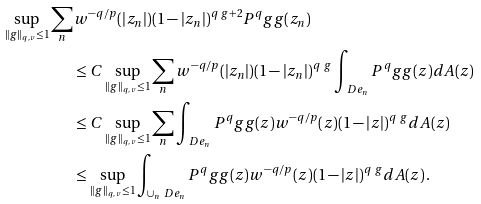<formula> <loc_0><loc_0><loc_500><loc_500>\sup _ { \| g \| _ { q , v } \leq 1 } \sum _ { n } & w ^ { - q / p } ( | z _ { n } | ) ( 1 - | z _ { n } | ) ^ { q \ g + 2 } P ^ { q } _ { \ } g g ( z _ { n } ) \\ & \leq C \sup _ { \| g \| _ { q , v } \leq 1 } \sum _ { n } w ^ { - q / p } ( | z _ { n } | ) ( 1 - | z _ { n } | ) ^ { q \ g } \int _ { \ D e _ { n } } P ^ { q } _ { \ } g g ( z ) d A ( z ) \\ & \leq C \sup _ { \| g \| _ { q , v } \leq 1 } \sum _ { n } \int _ { \ D e _ { n } } P ^ { q } _ { \ } g g ( z ) w ^ { - q / p } ( z ) ( 1 - | z | ) ^ { q \ g } d A ( z ) \\ & \leq \sup _ { \| g \| _ { q , v } \leq 1 } \int _ { \cup _ { n } \ D e _ { n } } P ^ { q } _ { \ } g g ( z ) w ^ { - q / p } ( z ) ( 1 - | z | ) ^ { q \ g } d A ( z ) \, .</formula> 